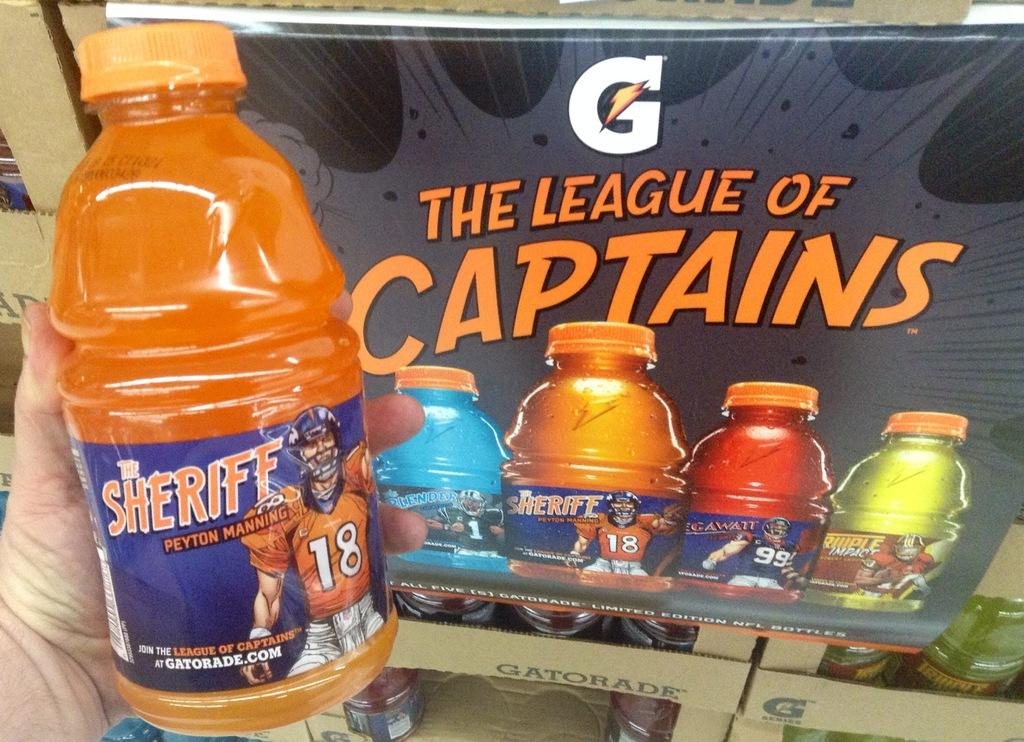Provide a one-sentence caption for the provided image. A person is holding a Gatorade sports drink in front of a Gatorade advertisement. 